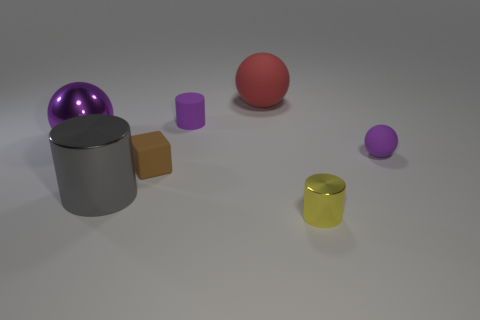Add 2 big purple metal things. How many objects exist? 9 Subtract all matte spheres. How many spheres are left? 1 Subtract all purple spheres. How many spheres are left? 1 Subtract all blocks. How many objects are left? 6 Subtract all purple balls. Subtract all red cylinders. How many balls are left? 1 Subtract all blue spheres. How many gray cylinders are left? 1 Subtract all cyan balls. Subtract all tiny rubber cylinders. How many objects are left? 6 Add 7 big metal objects. How many big metal objects are left? 9 Add 4 large red metallic objects. How many large red metallic objects exist? 4 Subtract 1 yellow cylinders. How many objects are left? 6 